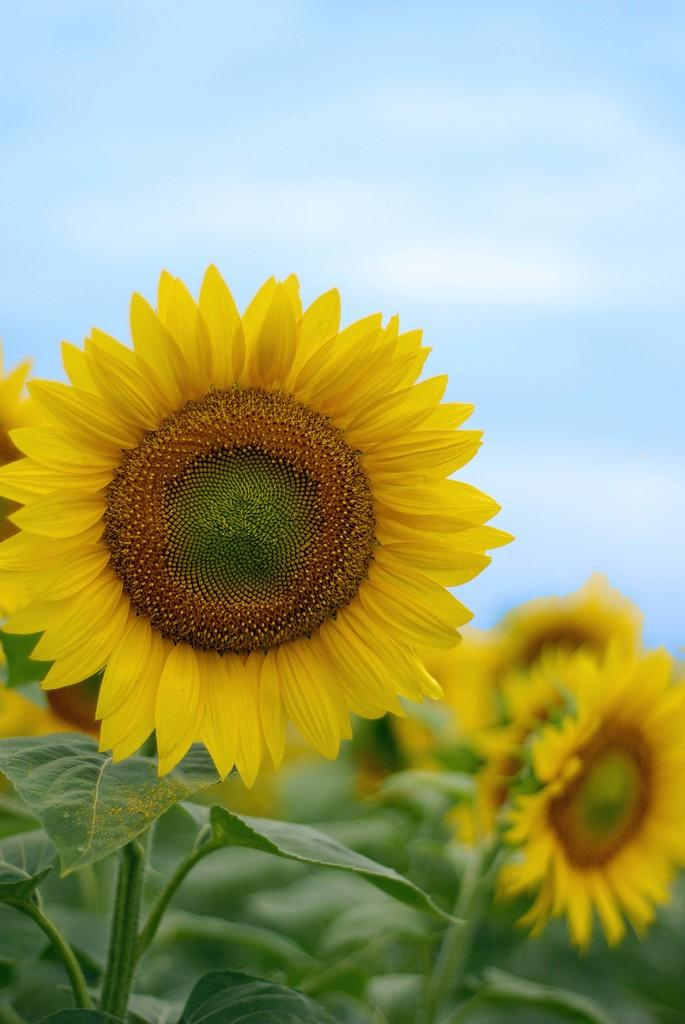What type of flowers are in the center of the image? There are sunflowers in the center of the image. What can be seen at the top of the image? The sky is visible at the top side of the image. What type of linen is being used to cover the train in the image? There is no train present in the image, so it is not possible to determine what type of linen might be used to cover it. 